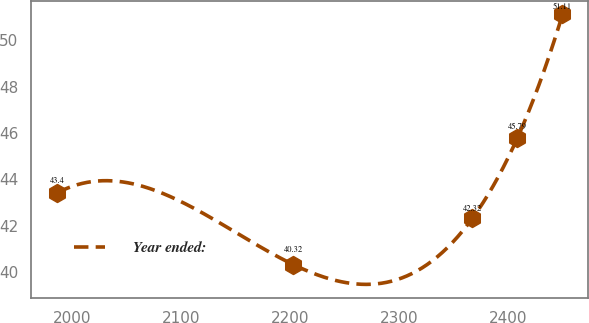Convert chart to OTSL. <chart><loc_0><loc_0><loc_500><loc_500><line_chart><ecel><fcel>Year ended:<nl><fcel>1986.1<fcel>43.4<nl><fcel>2202.72<fcel>40.32<nl><fcel>2367.02<fcel>42.32<nl><fcel>2408.26<fcel>45.79<nl><fcel>2449.5<fcel>51.11<nl></chart> 